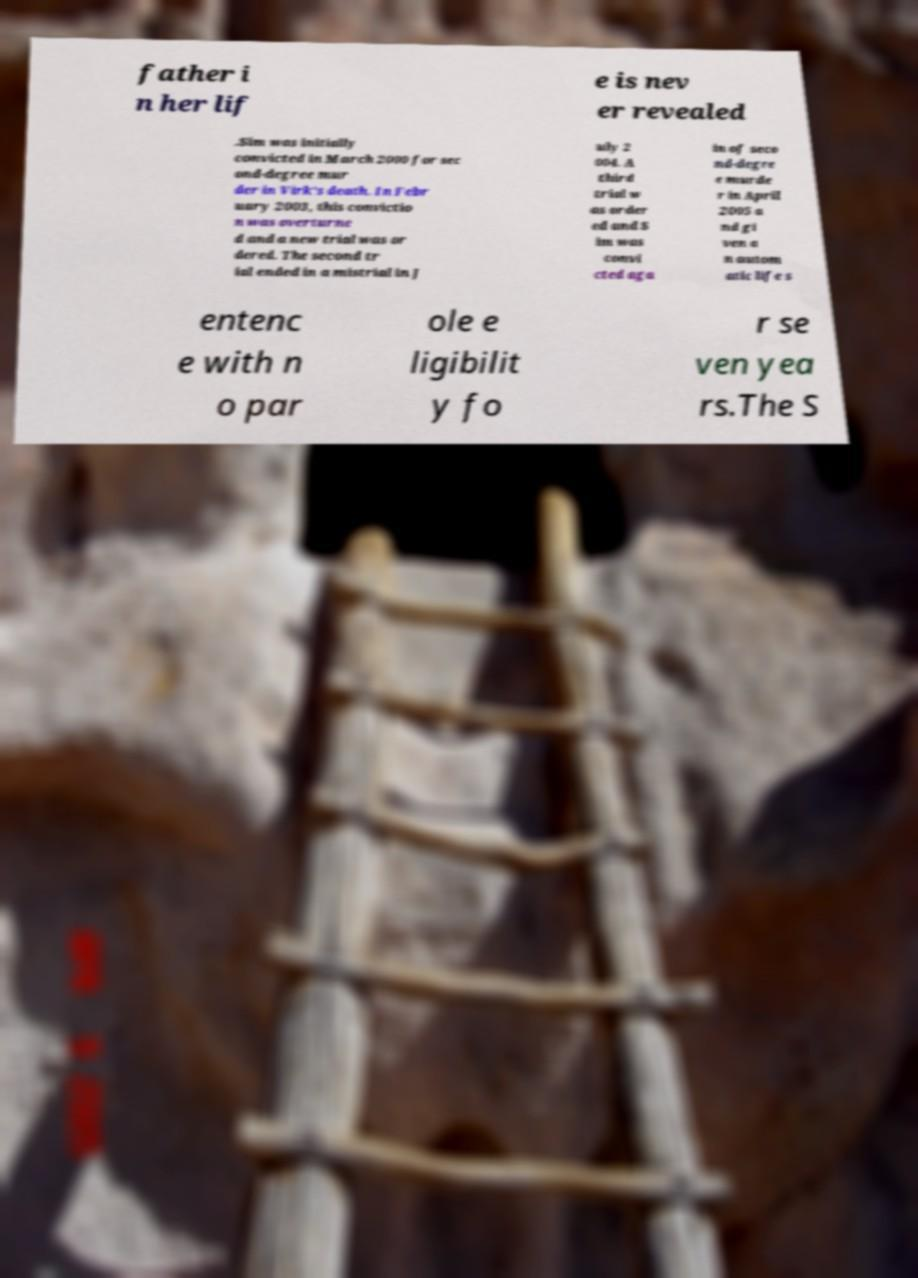I need the written content from this picture converted into text. Can you do that? father i n her lif e is nev er revealed .Sim was initially convicted in March 2000 for sec ond-degree mur der in Virk's death. In Febr uary 2003, this convictio n was overturne d and a new trial was or dered. The second tr ial ended in a mistrial in J uly 2 004. A third trial w as order ed and S im was convi cted aga in of seco nd-degre e murde r in April 2005 a nd gi ven a n autom atic life s entenc e with n o par ole e ligibilit y fo r se ven yea rs.The S 